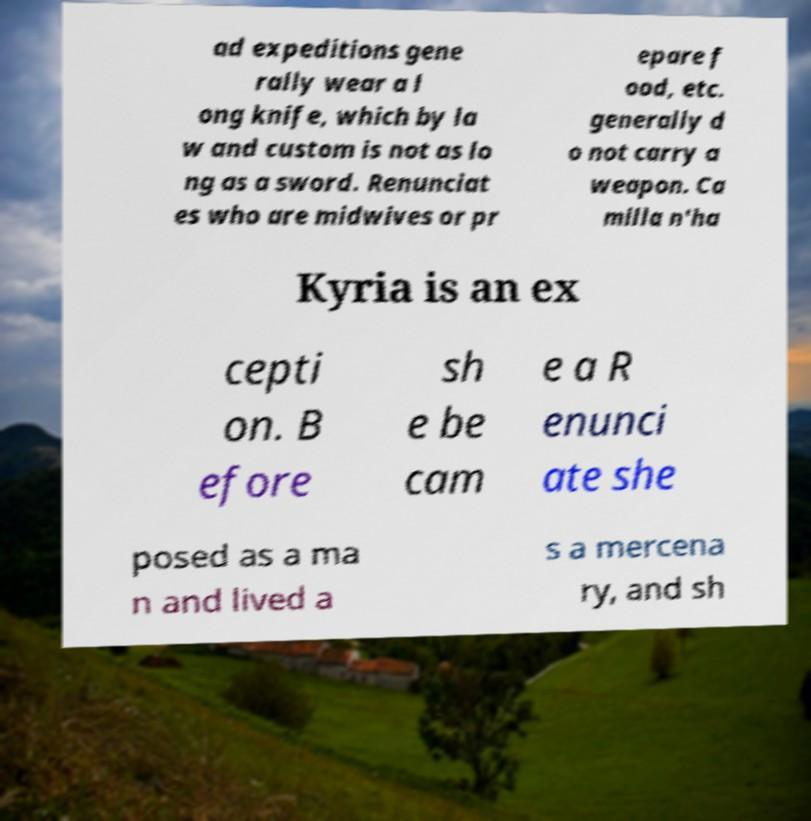For documentation purposes, I need the text within this image transcribed. Could you provide that? ad expeditions gene rally wear a l ong knife, which by la w and custom is not as lo ng as a sword. Renunciat es who are midwives or pr epare f ood, etc. generally d o not carry a weapon. Ca milla n'ha Kyria is an ex cepti on. B efore sh e be cam e a R enunci ate she posed as a ma n and lived a s a mercena ry, and sh 